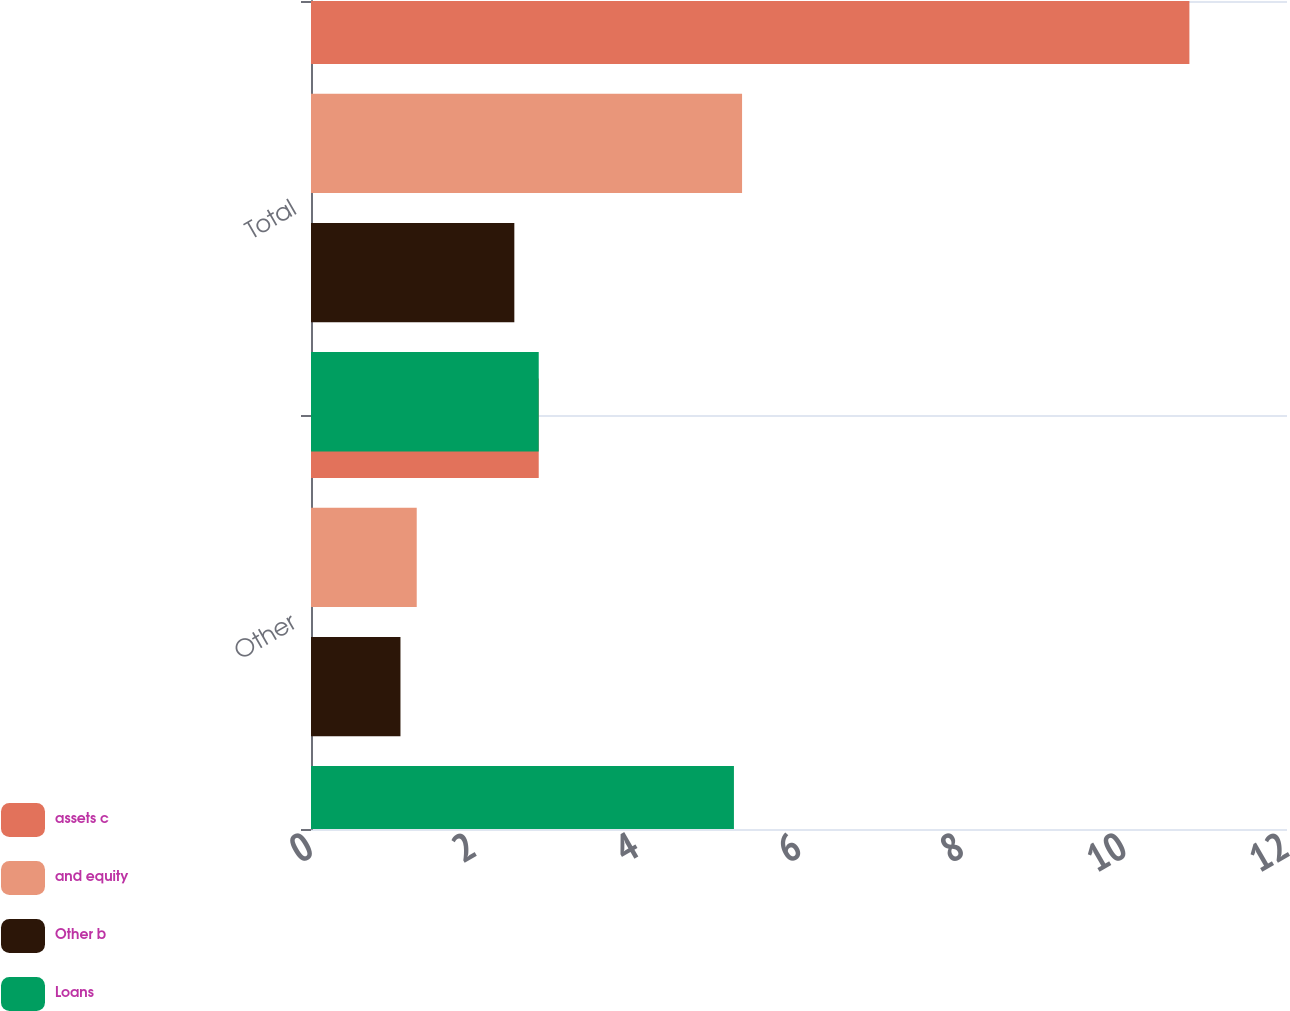<chart> <loc_0><loc_0><loc_500><loc_500><stacked_bar_chart><ecel><fcel>Other<fcel>Total<nl><fcel>assets c<fcel>2.8<fcel>10.8<nl><fcel>and equity<fcel>1.3<fcel>5.3<nl><fcel>Other b<fcel>1.1<fcel>2.5<nl><fcel>Loans<fcel>5.2<fcel>2.8<nl></chart> 